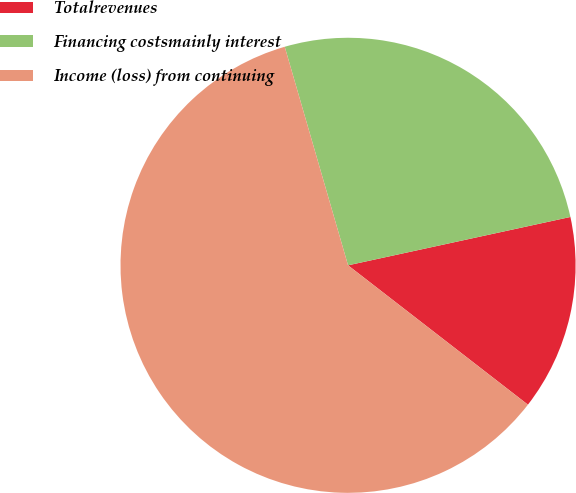Convert chart. <chart><loc_0><loc_0><loc_500><loc_500><pie_chart><fcel>Totalrevenues<fcel>Financing costsmainly interest<fcel>Income (loss) from continuing<nl><fcel>13.9%<fcel>26.08%<fcel>60.02%<nl></chart> 